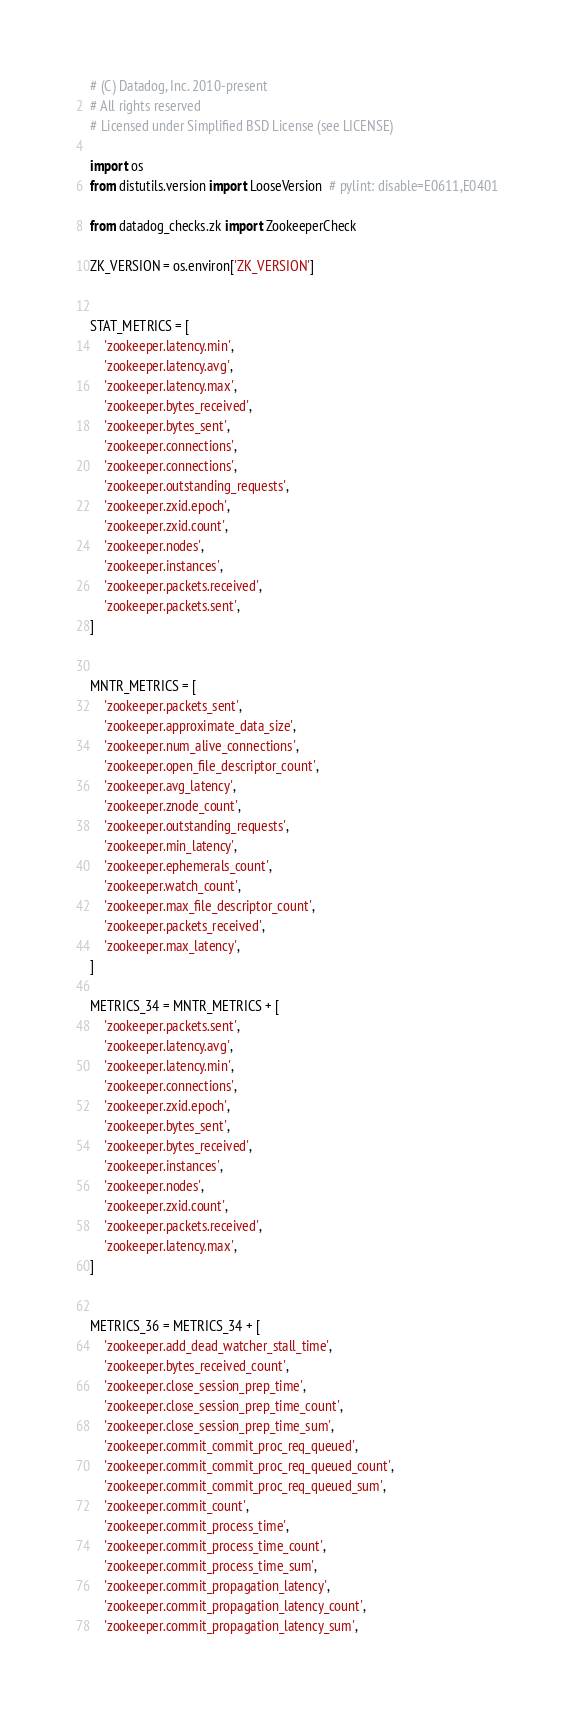Convert code to text. <code><loc_0><loc_0><loc_500><loc_500><_Python_># (C) Datadog, Inc. 2010-present
# All rights reserved
# Licensed under Simplified BSD License (see LICENSE)

import os
from distutils.version import LooseVersion  # pylint: disable=E0611,E0401

from datadog_checks.zk import ZookeeperCheck

ZK_VERSION = os.environ['ZK_VERSION']


STAT_METRICS = [
    'zookeeper.latency.min',
    'zookeeper.latency.avg',
    'zookeeper.latency.max',
    'zookeeper.bytes_received',
    'zookeeper.bytes_sent',
    'zookeeper.connections',
    'zookeeper.connections',
    'zookeeper.outstanding_requests',
    'zookeeper.zxid.epoch',
    'zookeeper.zxid.count',
    'zookeeper.nodes',
    'zookeeper.instances',
    'zookeeper.packets.received',
    'zookeeper.packets.sent',
]


MNTR_METRICS = [
    'zookeeper.packets_sent',
    'zookeeper.approximate_data_size',
    'zookeeper.num_alive_connections',
    'zookeeper.open_file_descriptor_count',
    'zookeeper.avg_latency',
    'zookeeper.znode_count',
    'zookeeper.outstanding_requests',
    'zookeeper.min_latency',
    'zookeeper.ephemerals_count',
    'zookeeper.watch_count',
    'zookeeper.max_file_descriptor_count',
    'zookeeper.packets_received',
    'zookeeper.max_latency',
]

METRICS_34 = MNTR_METRICS + [
    'zookeeper.packets.sent',
    'zookeeper.latency.avg',
    'zookeeper.latency.min',
    'zookeeper.connections',
    'zookeeper.zxid.epoch',
    'zookeeper.bytes_sent',
    'zookeeper.bytes_received',
    'zookeeper.instances',
    'zookeeper.nodes',
    'zookeeper.zxid.count',
    'zookeeper.packets.received',
    'zookeeper.latency.max',
]


METRICS_36 = METRICS_34 + [
    'zookeeper.add_dead_watcher_stall_time',
    'zookeeper.bytes_received_count',
    'zookeeper.close_session_prep_time',
    'zookeeper.close_session_prep_time_count',
    'zookeeper.close_session_prep_time_sum',
    'zookeeper.commit_commit_proc_req_queued',
    'zookeeper.commit_commit_proc_req_queued_count',
    'zookeeper.commit_commit_proc_req_queued_sum',
    'zookeeper.commit_count',
    'zookeeper.commit_process_time',
    'zookeeper.commit_process_time_count',
    'zookeeper.commit_process_time_sum',
    'zookeeper.commit_propagation_latency',
    'zookeeper.commit_propagation_latency_count',
    'zookeeper.commit_propagation_latency_sum',</code> 